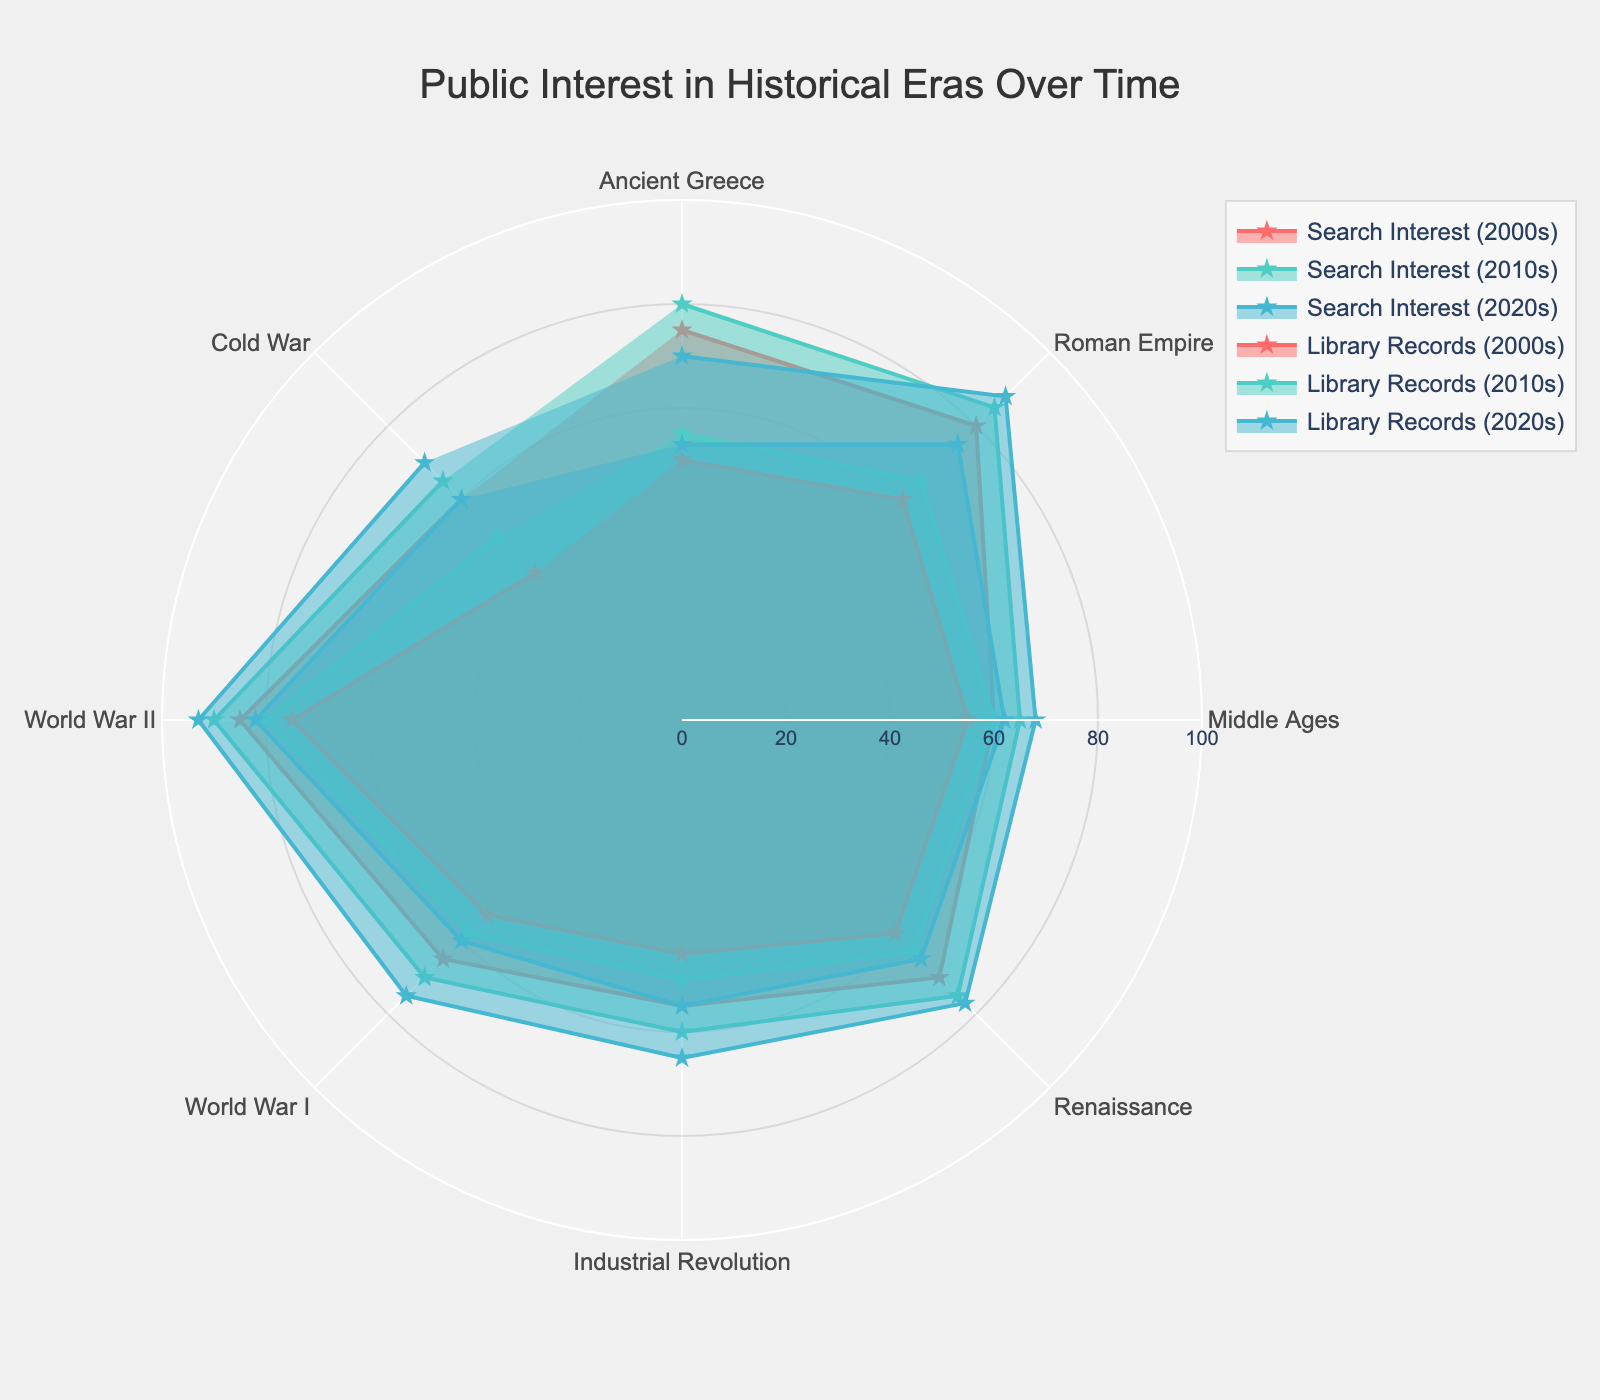What is the title of the radar chart? The title of the chart is written at the top center. Reading it will provide the required information.
Answer: Public Interest in Historical Eras Over Time Which historical era had the highest search interest in the 2020s? By looking at the section of the radar chart corresponding to search interest in the 2020s and identifying the longest segment, we see that World War II stands out.
Answer: World War II What is the difference in search interest for the Industrial Revolution between the 2000s and 2020s? Subtract the search interest of the Industrial Revolution in the 2000s (55) from that in the 2020s (65). The result is 10.
Answer: 10 Which historical era saw the most significant increase in library records from the 2000s to the 2020s? Examining the values for library records in the 2000s and 2020s for all eras and calculating the differences, the Roman Empire shows the largest increase (75 - 60 = 15).
Answer: Roman Empire Compare the search interest in the Middle Ages and Renaissance in the 2010s. Which era had higher interest? Check the radar chart sections for the 2010s search interest for both the Middle Ages (65) and the Renaissance (75). The Renaissance has a higher value.
Answer: Renaissance What is the average search interest for World War II over the three decades? Add the search interest values for World War II over the 2000s (85), 2010s (90), and 2020s (93), then divide by 3. The average is (85 + 90 + 93) / 3 = 89.33.
Answer: 89.33 In which decade did the search interest in Ancient Greece decrease compared to the previous decade? Comparing the search interest values for Ancient Greece in the 2000s (75), 2010s (80), and 2020s (70), the interest decreased from the 2010s to the 2020s.
Answer: 2020s Which historical era has the smallest range of library records values over the three decades? Subtract the smallest library record value from the largest one for each era and compare these ranges. For Ancient Greece, the range is (55 - 50 = 5), which is the smallest.
Answer: Ancient Greece How does the public interest in the Cold War in the 2020s compare to the Middle Ages in the same period? Compare the radar chart segments for the 2020s for both eras, Cold War (70) and Middle Ages (68). The Cold War has a higher search interest.
Answer: Cold War What is the median library records value for World War I over the three decades? Arrange the library record values for World War I in ascending order (53, 58, 60). The middle value, which is the median, is 58.
Answer: 58 